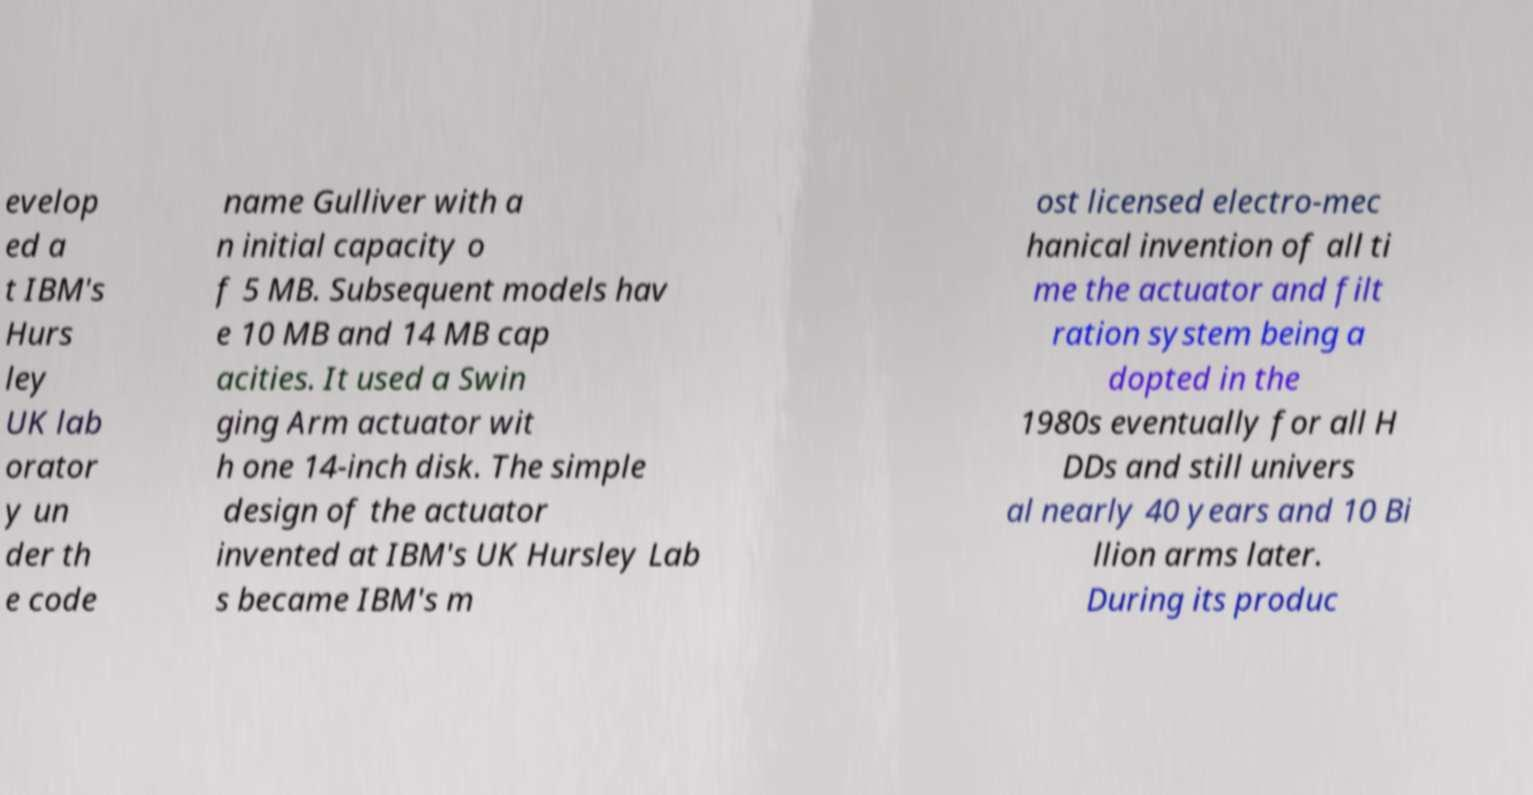For documentation purposes, I need the text within this image transcribed. Could you provide that? evelop ed a t IBM's Hurs ley UK lab orator y un der th e code name Gulliver with a n initial capacity o f 5 MB. Subsequent models hav e 10 MB and 14 MB cap acities. It used a Swin ging Arm actuator wit h one 14-inch disk. The simple design of the actuator invented at IBM's UK Hursley Lab s became IBM's m ost licensed electro-mec hanical invention of all ti me the actuator and filt ration system being a dopted in the 1980s eventually for all H DDs and still univers al nearly 40 years and 10 Bi llion arms later. During its produc 